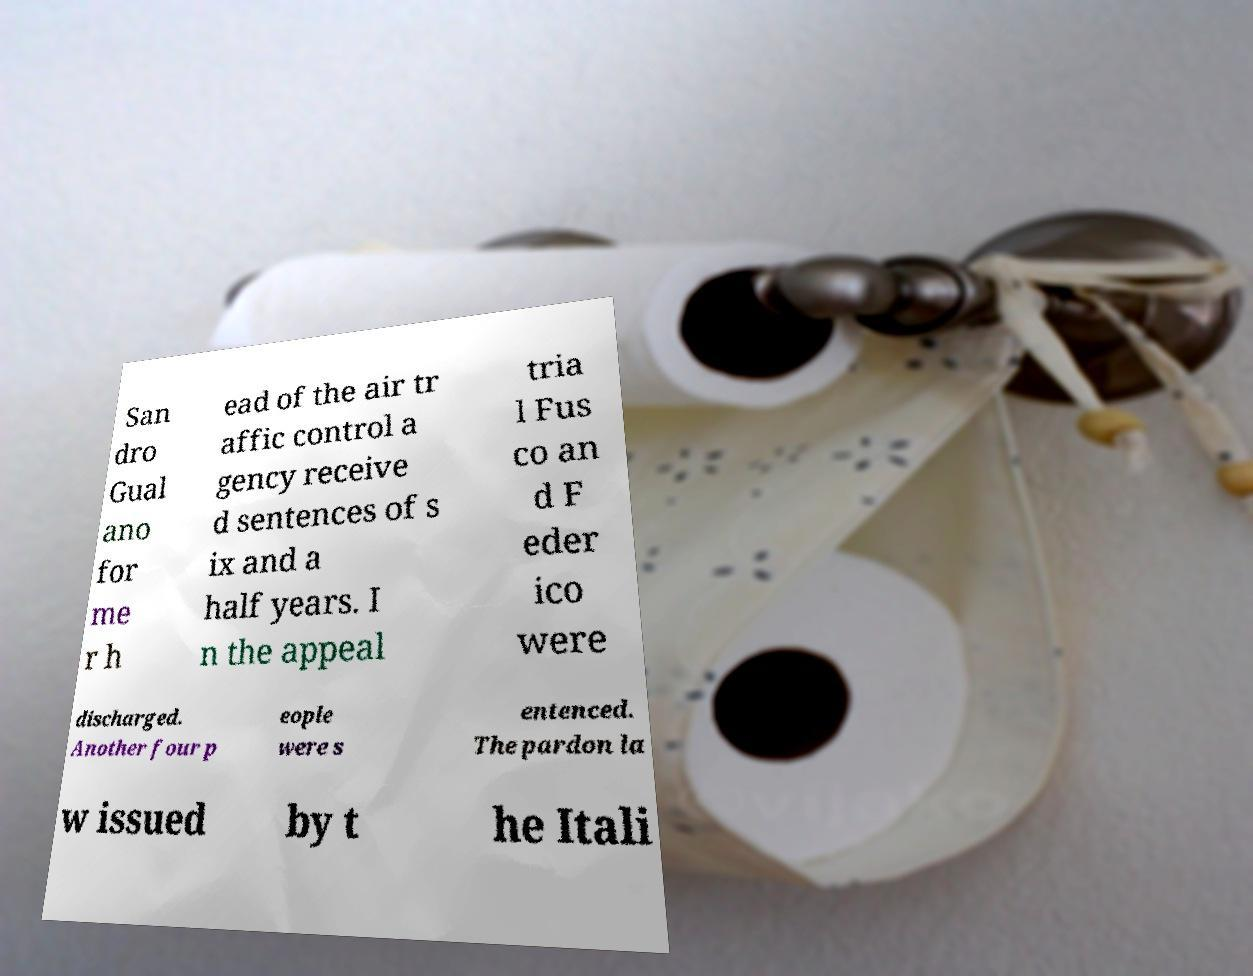Could you assist in decoding the text presented in this image and type it out clearly? San dro Gual ano for me r h ead of the air tr affic control a gency receive d sentences of s ix and a half years. I n the appeal tria l Fus co an d F eder ico were discharged. Another four p eople were s entenced. The pardon la w issued by t he Itali 